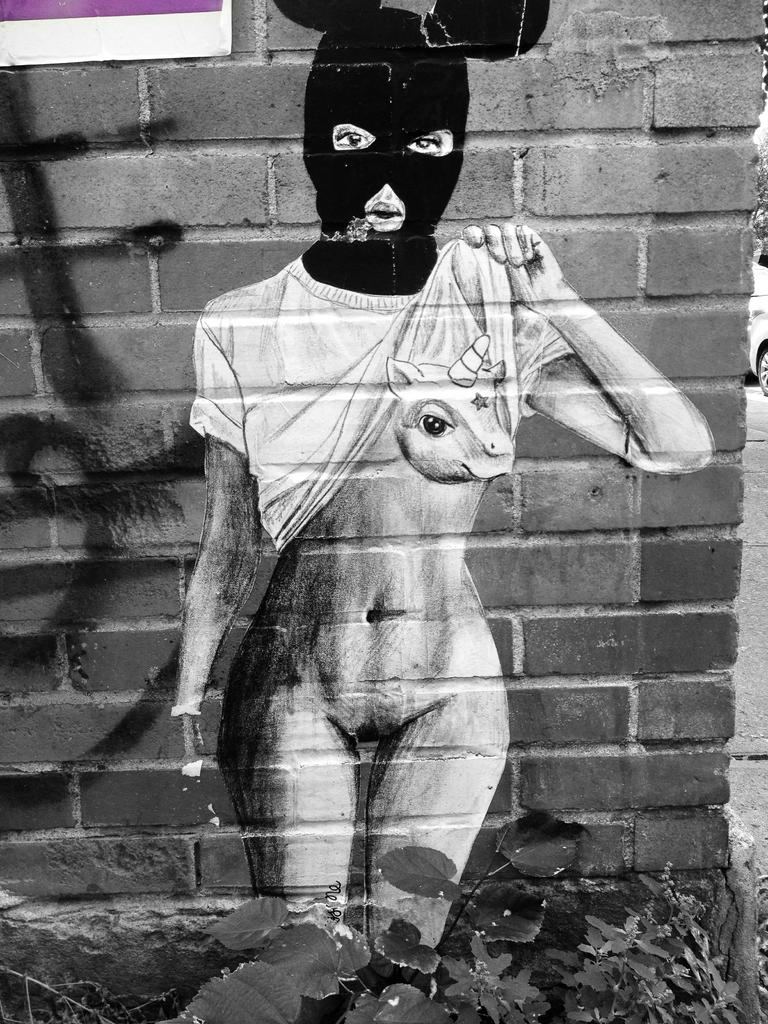What is present on the wall in the image? A girl is painting on the wall in the image. What is the girl doing in the image? The girl is painting on the wall. What can be seen at the bottom of the image? There are leaves visible at the bottom of the image. What type of jelly is the girl using to paint on the wall? There is no jelly present in the image; the girl is using paint to create her artwork on the wall. What musical instrument is the girl playing while painting on the wall? There is no musical instrument present in the image; the girl is focused solely on painting on the wall. 